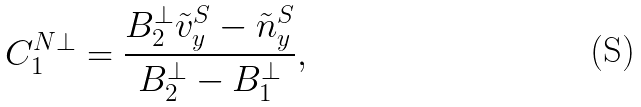<formula> <loc_0><loc_0><loc_500><loc_500>C ^ { N \bot } _ { 1 } = \frac { B ^ { \bot } _ { 2 } \tilde { v } _ { y } ^ { S } - \tilde { n } _ { y } ^ { S } } { B ^ { \bot } _ { 2 } - B ^ { \bot } _ { 1 } } ,</formula> 